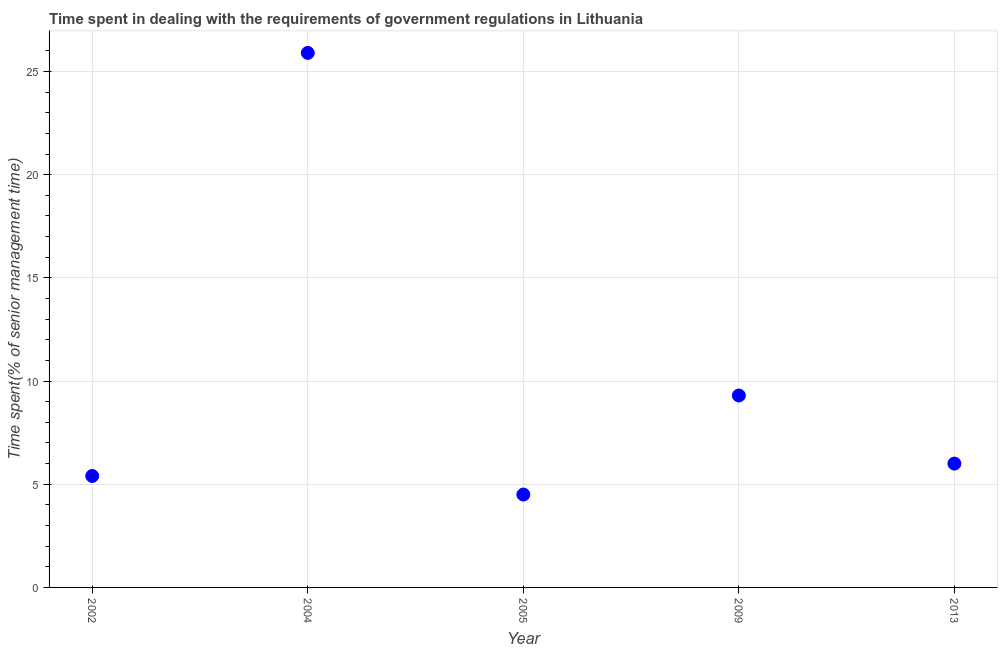What is the time spent in dealing with government regulations in 2005?
Offer a very short reply. 4.5. Across all years, what is the maximum time spent in dealing with government regulations?
Provide a succinct answer. 25.9. What is the sum of the time spent in dealing with government regulations?
Offer a terse response. 51.1. What is the difference between the time spent in dealing with government regulations in 2002 and 2013?
Your answer should be very brief. -0.6. What is the average time spent in dealing with government regulations per year?
Give a very brief answer. 10.22. What is the ratio of the time spent in dealing with government regulations in 2009 to that in 2013?
Give a very brief answer. 1.55. Is the time spent in dealing with government regulations in 2005 less than that in 2013?
Provide a succinct answer. Yes. Is the difference between the time spent in dealing with government regulations in 2002 and 2009 greater than the difference between any two years?
Offer a very short reply. No. What is the difference between the highest and the second highest time spent in dealing with government regulations?
Provide a short and direct response. 16.6. What is the difference between the highest and the lowest time spent in dealing with government regulations?
Give a very brief answer. 21.4. In how many years, is the time spent in dealing with government regulations greater than the average time spent in dealing with government regulations taken over all years?
Give a very brief answer. 1. Does the time spent in dealing with government regulations monotonically increase over the years?
Ensure brevity in your answer.  No. What is the title of the graph?
Ensure brevity in your answer.  Time spent in dealing with the requirements of government regulations in Lithuania. What is the label or title of the X-axis?
Offer a very short reply. Year. What is the label or title of the Y-axis?
Make the answer very short. Time spent(% of senior management time). What is the Time spent(% of senior management time) in 2002?
Make the answer very short. 5.4. What is the Time spent(% of senior management time) in 2004?
Your response must be concise. 25.9. What is the Time spent(% of senior management time) in 2005?
Your response must be concise. 4.5. What is the Time spent(% of senior management time) in 2009?
Offer a terse response. 9.3. What is the Time spent(% of senior management time) in 2013?
Ensure brevity in your answer.  6. What is the difference between the Time spent(% of senior management time) in 2002 and 2004?
Provide a succinct answer. -20.5. What is the difference between the Time spent(% of senior management time) in 2004 and 2005?
Keep it short and to the point. 21.4. What is the difference between the Time spent(% of senior management time) in 2004 and 2013?
Keep it short and to the point. 19.9. What is the difference between the Time spent(% of senior management time) in 2009 and 2013?
Offer a very short reply. 3.3. What is the ratio of the Time spent(% of senior management time) in 2002 to that in 2004?
Your response must be concise. 0.21. What is the ratio of the Time spent(% of senior management time) in 2002 to that in 2009?
Ensure brevity in your answer.  0.58. What is the ratio of the Time spent(% of senior management time) in 2002 to that in 2013?
Offer a very short reply. 0.9. What is the ratio of the Time spent(% of senior management time) in 2004 to that in 2005?
Provide a short and direct response. 5.76. What is the ratio of the Time spent(% of senior management time) in 2004 to that in 2009?
Ensure brevity in your answer.  2.79. What is the ratio of the Time spent(% of senior management time) in 2004 to that in 2013?
Your response must be concise. 4.32. What is the ratio of the Time spent(% of senior management time) in 2005 to that in 2009?
Provide a short and direct response. 0.48. What is the ratio of the Time spent(% of senior management time) in 2005 to that in 2013?
Give a very brief answer. 0.75. What is the ratio of the Time spent(% of senior management time) in 2009 to that in 2013?
Your response must be concise. 1.55. 